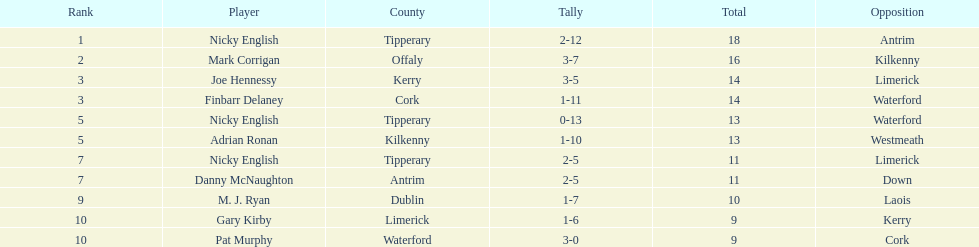How many people are on the list? 9. 